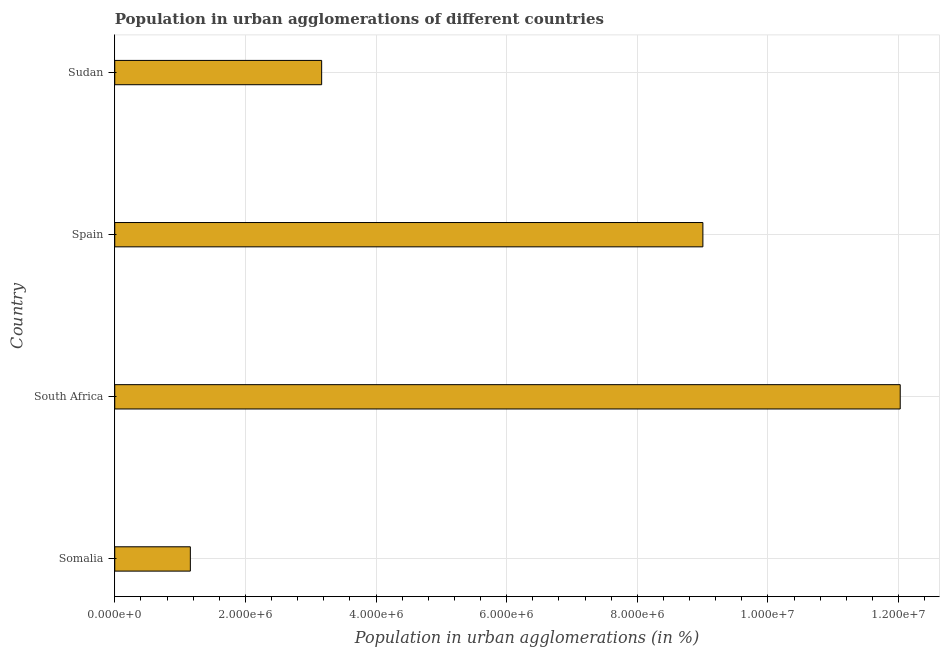Does the graph contain any zero values?
Your response must be concise. No. What is the title of the graph?
Your answer should be compact. Population in urban agglomerations of different countries. What is the label or title of the X-axis?
Your answer should be compact. Population in urban agglomerations (in %). What is the label or title of the Y-axis?
Keep it short and to the point. Country. What is the population in urban agglomerations in Sudan?
Provide a short and direct response. 3.17e+06. Across all countries, what is the maximum population in urban agglomerations?
Offer a terse response. 1.20e+07. Across all countries, what is the minimum population in urban agglomerations?
Make the answer very short. 1.16e+06. In which country was the population in urban agglomerations maximum?
Offer a terse response. South Africa. In which country was the population in urban agglomerations minimum?
Offer a terse response. Somalia. What is the sum of the population in urban agglomerations?
Your answer should be very brief. 2.54e+07. What is the difference between the population in urban agglomerations in Somalia and Sudan?
Offer a terse response. -2.01e+06. What is the average population in urban agglomerations per country?
Give a very brief answer. 6.34e+06. What is the median population in urban agglomerations?
Keep it short and to the point. 6.09e+06. What is the ratio of the population in urban agglomerations in South Africa to that in Sudan?
Your response must be concise. 3.8. What is the difference between the highest and the second highest population in urban agglomerations?
Your answer should be very brief. 3.02e+06. What is the difference between the highest and the lowest population in urban agglomerations?
Your answer should be very brief. 1.09e+07. In how many countries, is the population in urban agglomerations greater than the average population in urban agglomerations taken over all countries?
Your response must be concise. 2. What is the Population in urban agglomerations (in %) in Somalia?
Offer a terse response. 1.16e+06. What is the Population in urban agglomerations (in %) of South Africa?
Your answer should be very brief. 1.20e+07. What is the Population in urban agglomerations (in %) of Spain?
Provide a succinct answer. 9.00e+06. What is the Population in urban agglomerations (in %) in Sudan?
Keep it short and to the point. 3.17e+06. What is the difference between the Population in urban agglomerations (in %) in Somalia and South Africa?
Ensure brevity in your answer.  -1.09e+07. What is the difference between the Population in urban agglomerations (in %) in Somalia and Spain?
Offer a very short reply. -7.85e+06. What is the difference between the Population in urban agglomerations (in %) in Somalia and Sudan?
Give a very brief answer. -2.01e+06. What is the difference between the Population in urban agglomerations (in %) in South Africa and Spain?
Keep it short and to the point. 3.02e+06. What is the difference between the Population in urban agglomerations (in %) in South Africa and Sudan?
Provide a short and direct response. 8.86e+06. What is the difference between the Population in urban agglomerations (in %) in Spain and Sudan?
Your answer should be very brief. 5.84e+06. What is the ratio of the Population in urban agglomerations (in %) in Somalia to that in South Africa?
Offer a very short reply. 0.1. What is the ratio of the Population in urban agglomerations (in %) in Somalia to that in Spain?
Your answer should be very brief. 0.13. What is the ratio of the Population in urban agglomerations (in %) in Somalia to that in Sudan?
Make the answer very short. 0.36. What is the ratio of the Population in urban agglomerations (in %) in South Africa to that in Spain?
Your answer should be compact. 1.34. What is the ratio of the Population in urban agglomerations (in %) in South Africa to that in Sudan?
Offer a terse response. 3.8. What is the ratio of the Population in urban agglomerations (in %) in Spain to that in Sudan?
Offer a very short reply. 2.84. 